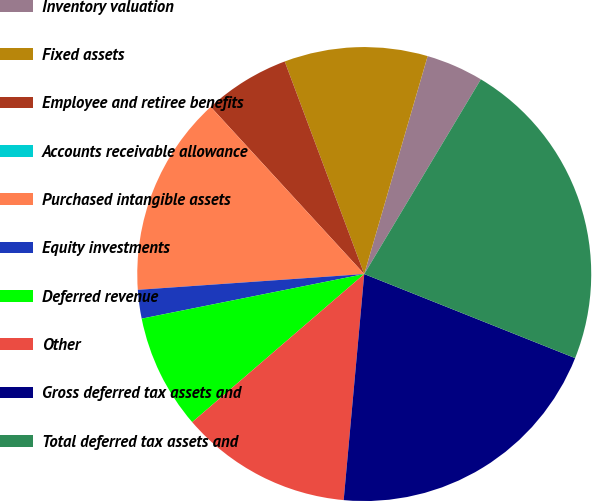Convert chart to OTSL. <chart><loc_0><loc_0><loc_500><loc_500><pie_chart><fcel>Inventory valuation<fcel>Fixed assets<fcel>Employee and retiree benefits<fcel>Accounts receivable allowance<fcel>Purchased intangible assets<fcel>Equity investments<fcel>Deferred revenue<fcel>Other<fcel>Gross deferred tax assets and<fcel>Total deferred tax assets and<nl><fcel>4.08%<fcel>10.2%<fcel>6.12%<fcel>0.0%<fcel>14.28%<fcel>2.04%<fcel>8.16%<fcel>12.24%<fcel>20.4%<fcel>22.44%<nl></chart> 